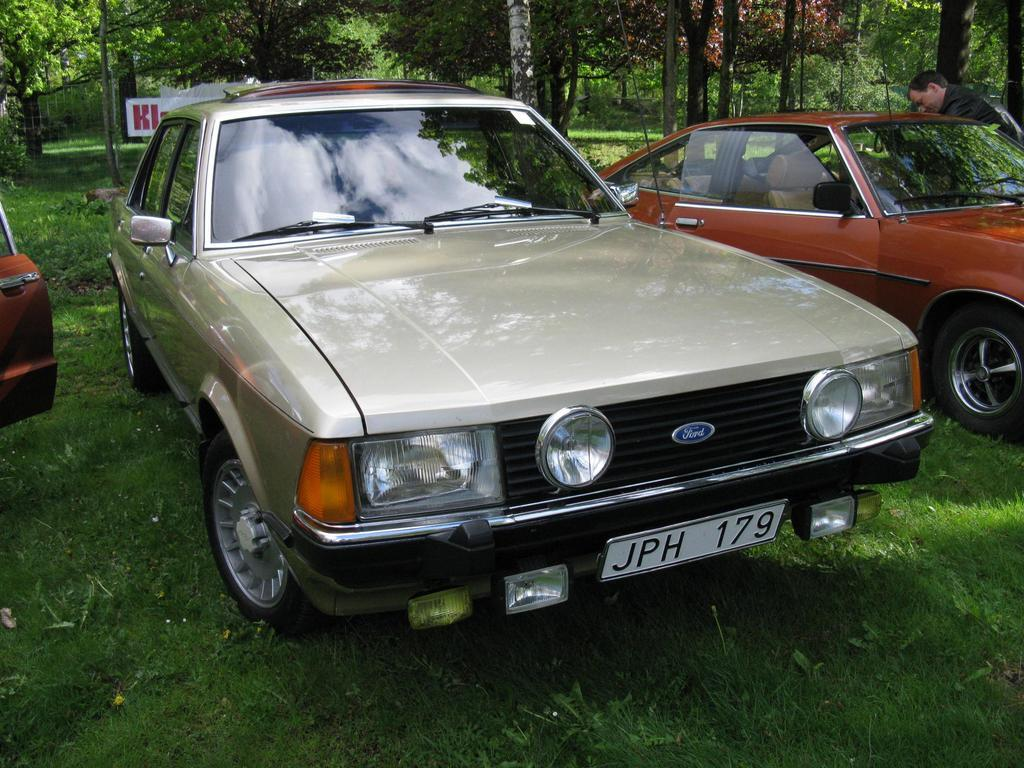What can be seen parked on the grass in the image? There are different cars parked on the grass in the image. What is visible in the background behind the cars? There are many trees behind the cars in the image. Can you describe the presence of a person in the image? Yes, there is a man beside the third car in the image. What type of jail can be seen in the image? There is no jail present in the image; it features cars parked on the grass and trees in the background. What position does the peace symbol hold in the image? There is no peace symbol present in the image. 